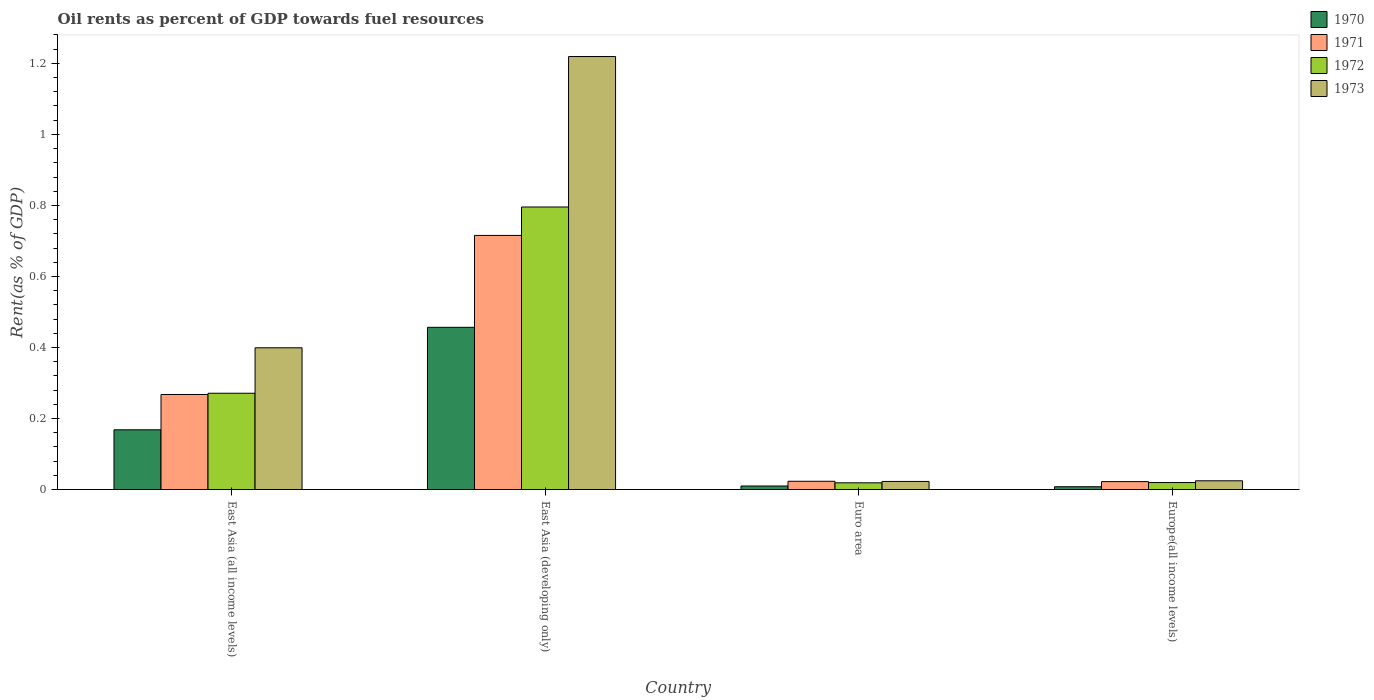How many different coloured bars are there?
Offer a terse response. 4. What is the label of the 4th group of bars from the left?
Your answer should be very brief. Europe(all income levels). What is the oil rent in 1971 in East Asia (developing only)?
Make the answer very short. 0.72. Across all countries, what is the maximum oil rent in 1972?
Keep it short and to the point. 0.8. Across all countries, what is the minimum oil rent in 1971?
Make the answer very short. 0.02. In which country was the oil rent in 1972 maximum?
Keep it short and to the point. East Asia (developing only). In which country was the oil rent in 1970 minimum?
Your answer should be very brief. Europe(all income levels). What is the total oil rent in 1973 in the graph?
Your answer should be compact. 1.67. What is the difference between the oil rent in 1973 in East Asia (all income levels) and that in Euro area?
Provide a succinct answer. 0.38. What is the difference between the oil rent in 1973 in East Asia (all income levels) and the oil rent in 1970 in East Asia (developing only)?
Your answer should be very brief. -0.06. What is the average oil rent in 1970 per country?
Your answer should be compact. 0.16. What is the difference between the oil rent of/in 1971 and oil rent of/in 1972 in Europe(all income levels)?
Offer a terse response. 0. What is the ratio of the oil rent in 1971 in Euro area to that in Europe(all income levels)?
Ensure brevity in your answer.  1.04. Is the oil rent in 1972 in East Asia (all income levels) less than that in Euro area?
Your answer should be compact. No. What is the difference between the highest and the second highest oil rent in 1971?
Keep it short and to the point. 0.69. What is the difference between the highest and the lowest oil rent in 1972?
Your answer should be very brief. 0.78. In how many countries, is the oil rent in 1970 greater than the average oil rent in 1970 taken over all countries?
Keep it short and to the point. 2. Is it the case that in every country, the sum of the oil rent in 1972 and oil rent in 1971 is greater than the sum of oil rent in 1973 and oil rent in 1970?
Your answer should be very brief. Yes. What does the 3rd bar from the left in Euro area represents?
Provide a short and direct response. 1972. Is it the case that in every country, the sum of the oil rent in 1970 and oil rent in 1971 is greater than the oil rent in 1973?
Keep it short and to the point. No. How many bars are there?
Give a very brief answer. 16. How many countries are there in the graph?
Your answer should be compact. 4. What is the difference between two consecutive major ticks on the Y-axis?
Ensure brevity in your answer.  0.2. Are the values on the major ticks of Y-axis written in scientific E-notation?
Provide a succinct answer. No. Does the graph contain any zero values?
Give a very brief answer. No. Does the graph contain grids?
Offer a very short reply. No. How are the legend labels stacked?
Your answer should be compact. Vertical. What is the title of the graph?
Give a very brief answer. Oil rents as percent of GDP towards fuel resources. Does "1990" appear as one of the legend labels in the graph?
Offer a terse response. No. What is the label or title of the X-axis?
Provide a succinct answer. Country. What is the label or title of the Y-axis?
Make the answer very short. Rent(as % of GDP). What is the Rent(as % of GDP) in 1970 in East Asia (all income levels)?
Keep it short and to the point. 0.17. What is the Rent(as % of GDP) in 1971 in East Asia (all income levels)?
Provide a short and direct response. 0.27. What is the Rent(as % of GDP) in 1972 in East Asia (all income levels)?
Your answer should be compact. 0.27. What is the Rent(as % of GDP) of 1973 in East Asia (all income levels)?
Give a very brief answer. 0.4. What is the Rent(as % of GDP) of 1970 in East Asia (developing only)?
Offer a very short reply. 0.46. What is the Rent(as % of GDP) in 1971 in East Asia (developing only)?
Offer a very short reply. 0.72. What is the Rent(as % of GDP) of 1972 in East Asia (developing only)?
Your answer should be compact. 0.8. What is the Rent(as % of GDP) in 1973 in East Asia (developing only)?
Provide a short and direct response. 1.22. What is the Rent(as % of GDP) of 1970 in Euro area?
Your response must be concise. 0.01. What is the Rent(as % of GDP) of 1971 in Euro area?
Give a very brief answer. 0.02. What is the Rent(as % of GDP) of 1972 in Euro area?
Offer a terse response. 0.02. What is the Rent(as % of GDP) in 1973 in Euro area?
Your answer should be very brief. 0.02. What is the Rent(as % of GDP) of 1970 in Europe(all income levels)?
Provide a short and direct response. 0.01. What is the Rent(as % of GDP) of 1971 in Europe(all income levels)?
Your answer should be very brief. 0.02. What is the Rent(as % of GDP) in 1972 in Europe(all income levels)?
Offer a terse response. 0.02. What is the Rent(as % of GDP) in 1973 in Europe(all income levels)?
Give a very brief answer. 0.02. Across all countries, what is the maximum Rent(as % of GDP) in 1970?
Your response must be concise. 0.46. Across all countries, what is the maximum Rent(as % of GDP) of 1971?
Your answer should be compact. 0.72. Across all countries, what is the maximum Rent(as % of GDP) in 1972?
Give a very brief answer. 0.8. Across all countries, what is the maximum Rent(as % of GDP) in 1973?
Your answer should be very brief. 1.22. Across all countries, what is the minimum Rent(as % of GDP) of 1970?
Offer a very short reply. 0.01. Across all countries, what is the minimum Rent(as % of GDP) in 1971?
Offer a terse response. 0.02. Across all countries, what is the minimum Rent(as % of GDP) of 1972?
Your response must be concise. 0.02. Across all countries, what is the minimum Rent(as % of GDP) of 1973?
Make the answer very short. 0.02. What is the total Rent(as % of GDP) of 1970 in the graph?
Ensure brevity in your answer.  0.64. What is the total Rent(as % of GDP) of 1971 in the graph?
Provide a short and direct response. 1.03. What is the total Rent(as % of GDP) in 1972 in the graph?
Give a very brief answer. 1.11. What is the total Rent(as % of GDP) in 1973 in the graph?
Your answer should be very brief. 1.67. What is the difference between the Rent(as % of GDP) in 1970 in East Asia (all income levels) and that in East Asia (developing only)?
Your answer should be compact. -0.29. What is the difference between the Rent(as % of GDP) of 1971 in East Asia (all income levels) and that in East Asia (developing only)?
Your answer should be very brief. -0.45. What is the difference between the Rent(as % of GDP) of 1972 in East Asia (all income levels) and that in East Asia (developing only)?
Your response must be concise. -0.52. What is the difference between the Rent(as % of GDP) of 1973 in East Asia (all income levels) and that in East Asia (developing only)?
Ensure brevity in your answer.  -0.82. What is the difference between the Rent(as % of GDP) in 1970 in East Asia (all income levels) and that in Euro area?
Give a very brief answer. 0.16. What is the difference between the Rent(as % of GDP) of 1971 in East Asia (all income levels) and that in Euro area?
Offer a terse response. 0.24. What is the difference between the Rent(as % of GDP) in 1972 in East Asia (all income levels) and that in Euro area?
Provide a short and direct response. 0.25. What is the difference between the Rent(as % of GDP) of 1973 in East Asia (all income levels) and that in Euro area?
Your answer should be compact. 0.38. What is the difference between the Rent(as % of GDP) of 1970 in East Asia (all income levels) and that in Europe(all income levels)?
Your response must be concise. 0.16. What is the difference between the Rent(as % of GDP) of 1971 in East Asia (all income levels) and that in Europe(all income levels)?
Offer a terse response. 0.25. What is the difference between the Rent(as % of GDP) in 1972 in East Asia (all income levels) and that in Europe(all income levels)?
Make the answer very short. 0.25. What is the difference between the Rent(as % of GDP) in 1973 in East Asia (all income levels) and that in Europe(all income levels)?
Ensure brevity in your answer.  0.37. What is the difference between the Rent(as % of GDP) in 1970 in East Asia (developing only) and that in Euro area?
Make the answer very short. 0.45. What is the difference between the Rent(as % of GDP) in 1971 in East Asia (developing only) and that in Euro area?
Make the answer very short. 0.69. What is the difference between the Rent(as % of GDP) of 1972 in East Asia (developing only) and that in Euro area?
Your answer should be compact. 0.78. What is the difference between the Rent(as % of GDP) of 1973 in East Asia (developing only) and that in Euro area?
Offer a terse response. 1.2. What is the difference between the Rent(as % of GDP) of 1970 in East Asia (developing only) and that in Europe(all income levels)?
Your response must be concise. 0.45. What is the difference between the Rent(as % of GDP) in 1971 in East Asia (developing only) and that in Europe(all income levels)?
Your response must be concise. 0.69. What is the difference between the Rent(as % of GDP) in 1972 in East Asia (developing only) and that in Europe(all income levels)?
Offer a very short reply. 0.78. What is the difference between the Rent(as % of GDP) of 1973 in East Asia (developing only) and that in Europe(all income levels)?
Give a very brief answer. 1.19. What is the difference between the Rent(as % of GDP) in 1970 in Euro area and that in Europe(all income levels)?
Provide a succinct answer. 0. What is the difference between the Rent(as % of GDP) in 1971 in Euro area and that in Europe(all income levels)?
Offer a very short reply. 0. What is the difference between the Rent(as % of GDP) in 1972 in Euro area and that in Europe(all income levels)?
Provide a succinct answer. -0. What is the difference between the Rent(as % of GDP) of 1973 in Euro area and that in Europe(all income levels)?
Your response must be concise. -0. What is the difference between the Rent(as % of GDP) in 1970 in East Asia (all income levels) and the Rent(as % of GDP) in 1971 in East Asia (developing only)?
Make the answer very short. -0.55. What is the difference between the Rent(as % of GDP) in 1970 in East Asia (all income levels) and the Rent(as % of GDP) in 1972 in East Asia (developing only)?
Keep it short and to the point. -0.63. What is the difference between the Rent(as % of GDP) of 1970 in East Asia (all income levels) and the Rent(as % of GDP) of 1973 in East Asia (developing only)?
Make the answer very short. -1.05. What is the difference between the Rent(as % of GDP) of 1971 in East Asia (all income levels) and the Rent(as % of GDP) of 1972 in East Asia (developing only)?
Make the answer very short. -0.53. What is the difference between the Rent(as % of GDP) of 1971 in East Asia (all income levels) and the Rent(as % of GDP) of 1973 in East Asia (developing only)?
Provide a short and direct response. -0.95. What is the difference between the Rent(as % of GDP) of 1972 in East Asia (all income levels) and the Rent(as % of GDP) of 1973 in East Asia (developing only)?
Ensure brevity in your answer.  -0.95. What is the difference between the Rent(as % of GDP) of 1970 in East Asia (all income levels) and the Rent(as % of GDP) of 1971 in Euro area?
Your response must be concise. 0.14. What is the difference between the Rent(as % of GDP) in 1970 in East Asia (all income levels) and the Rent(as % of GDP) in 1972 in Euro area?
Provide a short and direct response. 0.15. What is the difference between the Rent(as % of GDP) of 1970 in East Asia (all income levels) and the Rent(as % of GDP) of 1973 in Euro area?
Your answer should be compact. 0.15. What is the difference between the Rent(as % of GDP) in 1971 in East Asia (all income levels) and the Rent(as % of GDP) in 1972 in Euro area?
Keep it short and to the point. 0.25. What is the difference between the Rent(as % of GDP) of 1971 in East Asia (all income levels) and the Rent(as % of GDP) of 1973 in Euro area?
Make the answer very short. 0.24. What is the difference between the Rent(as % of GDP) in 1972 in East Asia (all income levels) and the Rent(as % of GDP) in 1973 in Euro area?
Your answer should be very brief. 0.25. What is the difference between the Rent(as % of GDP) of 1970 in East Asia (all income levels) and the Rent(as % of GDP) of 1971 in Europe(all income levels)?
Offer a terse response. 0.15. What is the difference between the Rent(as % of GDP) in 1970 in East Asia (all income levels) and the Rent(as % of GDP) in 1972 in Europe(all income levels)?
Give a very brief answer. 0.15. What is the difference between the Rent(as % of GDP) in 1970 in East Asia (all income levels) and the Rent(as % of GDP) in 1973 in Europe(all income levels)?
Provide a succinct answer. 0.14. What is the difference between the Rent(as % of GDP) of 1971 in East Asia (all income levels) and the Rent(as % of GDP) of 1972 in Europe(all income levels)?
Give a very brief answer. 0.25. What is the difference between the Rent(as % of GDP) in 1971 in East Asia (all income levels) and the Rent(as % of GDP) in 1973 in Europe(all income levels)?
Offer a terse response. 0.24. What is the difference between the Rent(as % of GDP) in 1972 in East Asia (all income levels) and the Rent(as % of GDP) in 1973 in Europe(all income levels)?
Your answer should be very brief. 0.25. What is the difference between the Rent(as % of GDP) of 1970 in East Asia (developing only) and the Rent(as % of GDP) of 1971 in Euro area?
Keep it short and to the point. 0.43. What is the difference between the Rent(as % of GDP) in 1970 in East Asia (developing only) and the Rent(as % of GDP) in 1972 in Euro area?
Your answer should be compact. 0.44. What is the difference between the Rent(as % of GDP) in 1970 in East Asia (developing only) and the Rent(as % of GDP) in 1973 in Euro area?
Make the answer very short. 0.43. What is the difference between the Rent(as % of GDP) of 1971 in East Asia (developing only) and the Rent(as % of GDP) of 1972 in Euro area?
Offer a very short reply. 0.7. What is the difference between the Rent(as % of GDP) of 1971 in East Asia (developing only) and the Rent(as % of GDP) of 1973 in Euro area?
Offer a very short reply. 0.69. What is the difference between the Rent(as % of GDP) of 1972 in East Asia (developing only) and the Rent(as % of GDP) of 1973 in Euro area?
Give a very brief answer. 0.77. What is the difference between the Rent(as % of GDP) in 1970 in East Asia (developing only) and the Rent(as % of GDP) in 1971 in Europe(all income levels)?
Your answer should be compact. 0.43. What is the difference between the Rent(as % of GDP) in 1970 in East Asia (developing only) and the Rent(as % of GDP) in 1972 in Europe(all income levels)?
Give a very brief answer. 0.44. What is the difference between the Rent(as % of GDP) of 1970 in East Asia (developing only) and the Rent(as % of GDP) of 1973 in Europe(all income levels)?
Provide a succinct answer. 0.43. What is the difference between the Rent(as % of GDP) in 1971 in East Asia (developing only) and the Rent(as % of GDP) in 1972 in Europe(all income levels)?
Provide a succinct answer. 0.7. What is the difference between the Rent(as % of GDP) in 1971 in East Asia (developing only) and the Rent(as % of GDP) in 1973 in Europe(all income levels)?
Provide a succinct answer. 0.69. What is the difference between the Rent(as % of GDP) of 1972 in East Asia (developing only) and the Rent(as % of GDP) of 1973 in Europe(all income levels)?
Keep it short and to the point. 0.77. What is the difference between the Rent(as % of GDP) of 1970 in Euro area and the Rent(as % of GDP) of 1971 in Europe(all income levels)?
Make the answer very short. -0.01. What is the difference between the Rent(as % of GDP) in 1970 in Euro area and the Rent(as % of GDP) in 1972 in Europe(all income levels)?
Your response must be concise. -0.01. What is the difference between the Rent(as % of GDP) of 1970 in Euro area and the Rent(as % of GDP) of 1973 in Europe(all income levels)?
Offer a terse response. -0.01. What is the difference between the Rent(as % of GDP) in 1971 in Euro area and the Rent(as % of GDP) in 1972 in Europe(all income levels)?
Ensure brevity in your answer.  0. What is the difference between the Rent(as % of GDP) in 1971 in Euro area and the Rent(as % of GDP) in 1973 in Europe(all income levels)?
Provide a succinct answer. -0. What is the difference between the Rent(as % of GDP) in 1972 in Euro area and the Rent(as % of GDP) in 1973 in Europe(all income levels)?
Ensure brevity in your answer.  -0.01. What is the average Rent(as % of GDP) of 1970 per country?
Your answer should be compact. 0.16. What is the average Rent(as % of GDP) in 1971 per country?
Provide a short and direct response. 0.26. What is the average Rent(as % of GDP) in 1972 per country?
Keep it short and to the point. 0.28. What is the average Rent(as % of GDP) in 1973 per country?
Your answer should be compact. 0.42. What is the difference between the Rent(as % of GDP) of 1970 and Rent(as % of GDP) of 1971 in East Asia (all income levels)?
Keep it short and to the point. -0.1. What is the difference between the Rent(as % of GDP) of 1970 and Rent(as % of GDP) of 1972 in East Asia (all income levels)?
Keep it short and to the point. -0.1. What is the difference between the Rent(as % of GDP) in 1970 and Rent(as % of GDP) in 1973 in East Asia (all income levels)?
Provide a succinct answer. -0.23. What is the difference between the Rent(as % of GDP) of 1971 and Rent(as % of GDP) of 1972 in East Asia (all income levels)?
Keep it short and to the point. -0. What is the difference between the Rent(as % of GDP) in 1971 and Rent(as % of GDP) in 1973 in East Asia (all income levels)?
Offer a very short reply. -0.13. What is the difference between the Rent(as % of GDP) of 1972 and Rent(as % of GDP) of 1973 in East Asia (all income levels)?
Ensure brevity in your answer.  -0.13. What is the difference between the Rent(as % of GDP) of 1970 and Rent(as % of GDP) of 1971 in East Asia (developing only)?
Provide a succinct answer. -0.26. What is the difference between the Rent(as % of GDP) of 1970 and Rent(as % of GDP) of 1972 in East Asia (developing only)?
Keep it short and to the point. -0.34. What is the difference between the Rent(as % of GDP) of 1970 and Rent(as % of GDP) of 1973 in East Asia (developing only)?
Provide a short and direct response. -0.76. What is the difference between the Rent(as % of GDP) of 1971 and Rent(as % of GDP) of 1972 in East Asia (developing only)?
Make the answer very short. -0.08. What is the difference between the Rent(as % of GDP) of 1971 and Rent(as % of GDP) of 1973 in East Asia (developing only)?
Make the answer very short. -0.5. What is the difference between the Rent(as % of GDP) in 1972 and Rent(as % of GDP) in 1973 in East Asia (developing only)?
Ensure brevity in your answer.  -0.42. What is the difference between the Rent(as % of GDP) in 1970 and Rent(as % of GDP) in 1971 in Euro area?
Your answer should be very brief. -0.01. What is the difference between the Rent(as % of GDP) of 1970 and Rent(as % of GDP) of 1972 in Euro area?
Keep it short and to the point. -0.01. What is the difference between the Rent(as % of GDP) in 1970 and Rent(as % of GDP) in 1973 in Euro area?
Provide a short and direct response. -0.01. What is the difference between the Rent(as % of GDP) in 1971 and Rent(as % of GDP) in 1972 in Euro area?
Make the answer very short. 0. What is the difference between the Rent(as % of GDP) of 1971 and Rent(as % of GDP) of 1973 in Euro area?
Keep it short and to the point. 0. What is the difference between the Rent(as % of GDP) of 1972 and Rent(as % of GDP) of 1973 in Euro area?
Give a very brief answer. -0. What is the difference between the Rent(as % of GDP) of 1970 and Rent(as % of GDP) of 1971 in Europe(all income levels)?
Offer a very short reply. -0.01. What is the difference between the Rent(as % of GDP) of 1970 and Rent(as % of GDP) of 1972 in Europe(all income levels)?
Your answer should be very brief. -0.01. What is the difference between the Rent(as % of GDP) in 1970 and Rent(as % of GDP) in 1973 in Europe(all income levels)?
Offer a terse response. -0.02. What is the difference between the Rent(as % of GDP) of 1971 and Rent(as % of GDP) of 1972 in Europe(all income levels)?
Keep it short and to the point. 0. What is the difference between the Rent(as % of GDP) of 1971 and Rent(as % of GDP) of 1973 in Europe(all income levels)?
Offer a terse response. -0. What is the difference between the Rent(as % of GDP) of 1972 and Rent(as % of GDP) of 1973 in Europe(all income levels)?
Your response must be concise. -0.01. What is the ratio of the Rent(as % of GDP) of 1970 in East Asia (all income levels) to that in East Asia (developing only)?
Ensure brevity in your answer.  0.37. What is the ratio of the Rent(as % of GDP) in 1971 in East Asia (all income levels) to that in East Asia (developing only)?
Your answer should be very brief. 0.37. What is the ratio of the Rent(as % of GDP) of 1972 in East Asia (all income levels) to that in East Asia (developing only)?
Offer a terse response. 0.34. What is the ratio of the Rent(as % of GDP) of 1973 in East Asia (all income levels) to that in East Asia (developing only)?
Make the answer very short. 0.33. What is the ratio of the Rent(as % of GDP) in 1970 in East Asia (all income levels) to that in Euro area?
Provide a short and direct response. 16.91. What is the ratio of the Rent(as % of GDP) in 1971 in East Asia (all income levels) to that in Euro area?
Your answer should be very brief. 11.52. What is the ratio of the Rent(as % of GDP) of 1972 in East Asia (all income levels) to that in Euro area?
Your answer should be compact. 14.36. What is the ratio of the Rent(as % of GDP) in 1973 in East Asia (all income levels) to that in Euro area?
Provide a succinct answer. 17.54. What is the ratio of the Rent(as % of GDP) of 1970 in East Asia (all income levels) to that in Europe(all income levels)?
Give a very brief answer. 21.46. What is the ratio of the Rent(as % of GDP) of 1971 in East Asia (all income levels) to that in Europe(all income levels)?
Your response must be concise. 12.01. What is the ratio of the Rent(as % of GDP) in 1972 in East Asia (all income levels) to that in Europe(all income levels)?
Your answer should be compact. 13.8. What is the ratio of the Rent(as % of GDP) of 1973 in East Asia (all income levels) to that in Europe(all income levels)?
Offer a terse response. 16.22. What is the ratio of the Rent(as % of GDP) of 1970 in East Asia (developing only) to that in Euro area?
Make the answer very short. 45.91. What is the ratio of the Rent(as % of GDP) in 1971 in East Asia (developing only) to that in Euro area?
Make the answer very short. 30.82. What is the ratio of the Rent(as % of GDP) of 1972 in East Asia (developing only) to that in Euro area?
Your response must be concise. 42.15. What is the ratio of the Rent(as % of GDP) of 1973 in East Asia (developing only) to that in Euro area?
Your response must be concise. 53.59. What is the ratio of the Rent(as % of GDP) of 1970 in East Asia (developing only) to that in Europe(all income levels)?
Your answer should be very brief. 58.27. What is the ratio of the Rent(as % of GDP) of 1971 in East Asia (developing only) to that in Europe(all income levels)?
Your answer should be compact. 32.13. What is the ratio of the Rent(as % of GDP) in 1972 in East Asia (developing only) to that in Europe(all income levels)?
Ensure brevity in your answer.  40.49. What is the ratio of the Rent(as % of GDP) in 1973 in East Asia (developing only) to that in Europe(all income levels)?
Offer a terse response. 49.55. What is the ratio of the Rent(as % of GDP) in 1970 in Euro area to that in Europe(all income levels)?
Give a very brief answer. 1.27. What is the ratio of the Rent(as % of GDP) in 1971 in Euro area to that in Europe(all income levels)?
Offer a very short reply. 1.04. What is the ratio of the Rent(as % of GDP) in 1972 in Euro area to that in Europe(all income levels)?
Your response must be concise. 0.96. What is the ratio of the Rent(as % of GDP) in 1973 in Euro area to that in Europe(all income levels)?
Offer a very short reply. 0.92. What is the difference between the highest and the second highest Rent(as % of GDP) in 1970?
Provide a succinct answer. 0.29. What is the difference between the highest and the second highest Rent(as % of GDP) of 1971?
Offer a very short reply. 0.45. What is the difference between the highest and the second highest Rent(as % of GDP) in 1972?
Offer a very short reply. 0.52. What is the difference between the highest and the second highest Rent(as % of GDP) in 1973?
Give a very brief answer. 0.82. What is the difference between the highest and the lowest Rent(as % of GDP) in 1970?
Your answer should be compact. 0.45. What is the difference between the highest and the lowest Rent(as % of GDP) in 1971?
Offer a terse response. 0.69. What is the difference between the highest and the lowest Rent(as % of GDP) in 1972?
Provide a short and direct response. 0.78. What is the difference between the highest and the lowest Rent(as % of GDP) of 1973?
Offer a terse response. 1.2. 